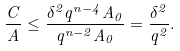Convert formula to latex. <formula><loc_0><loc_0><loc_500><loc_500>\frac { C } { A } \leq \frac { \delta ^ { 2 } q ^ { n - 4 } A _ { 0 } } { q ^ { n - 2 } A _ { 0 } } = \frac { \delta ^ { 2 } } { q ^ { 2 } } .</formula> 